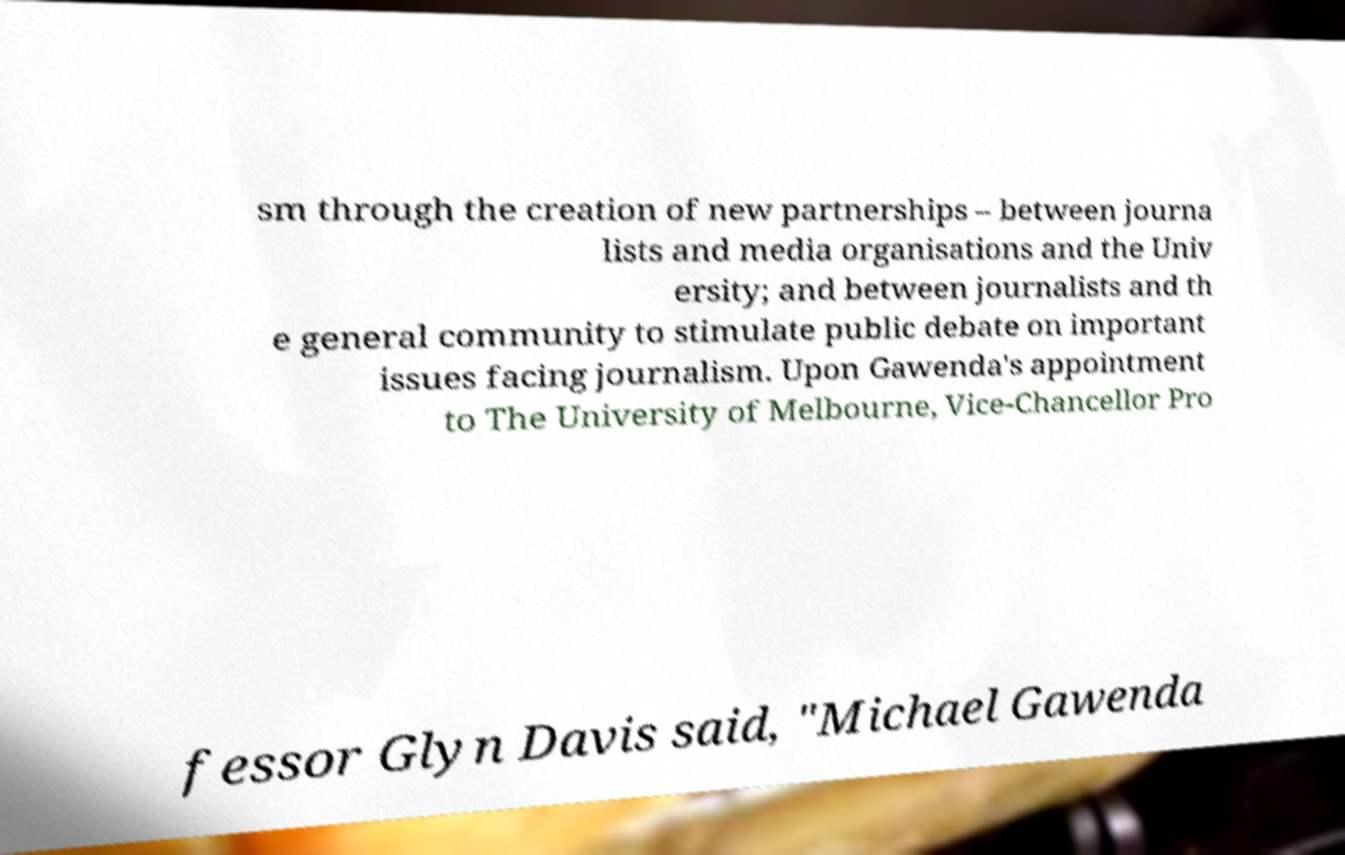Could you extract and type out the text from this image? sm through the creation of new partnerships – between journa lists and media organisations and the Univ ersity; and between journalists and th e general community to stimulate public debate on important issues facing journalism. Upon Gawenda's appointment to The University of Melbourne, Vice-Chancellor Pro fessor Glyn Davis said, "Michael Gawenda 